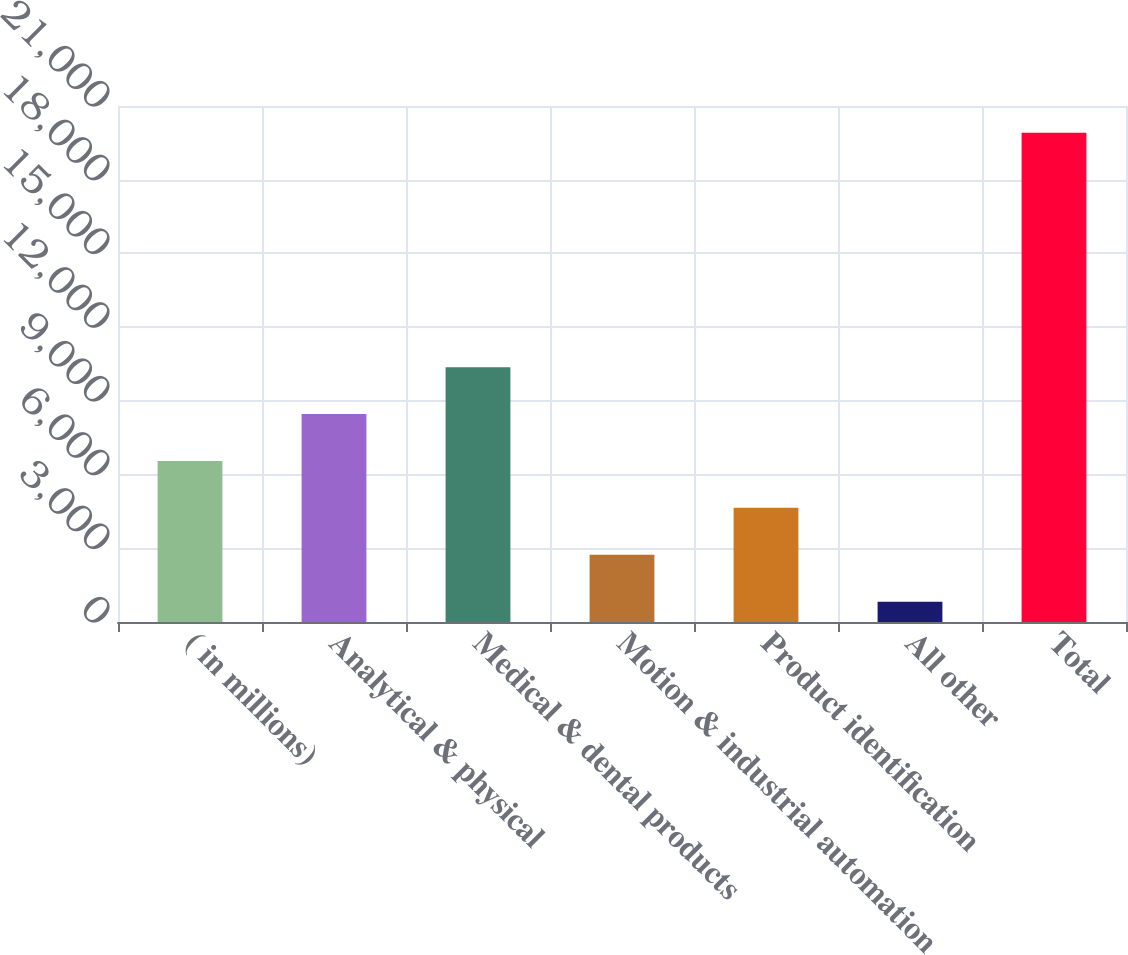<chart> <loc_0><loc_0><loc_500><loc_500><bar_chart><fcel>( in millions)<fcel>Analytical & physical<fcel>Medical & dental products<fcel>Motion & industrial automation<fcel>Product identification<fcel>All other<fcel>Total<nl><fcel>6553.81<fcel>8462.38<fcel>10371<fcel>2736.67<fcel>4645.24<fcel>828.1<fcel>19913.8<nl></chart> 